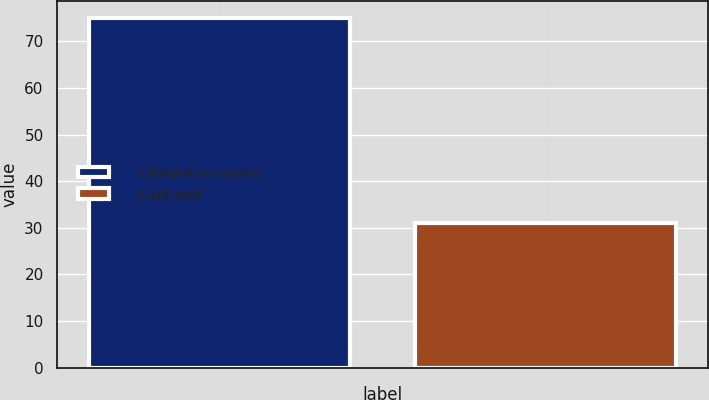Convert chart. <chart><loc_0><loc_0><loc_500><loc_500><bar_chart><fcel>Charged to expense<fcel>Cash paid<nl><fcel>75<fcel>31<nl></chart> 